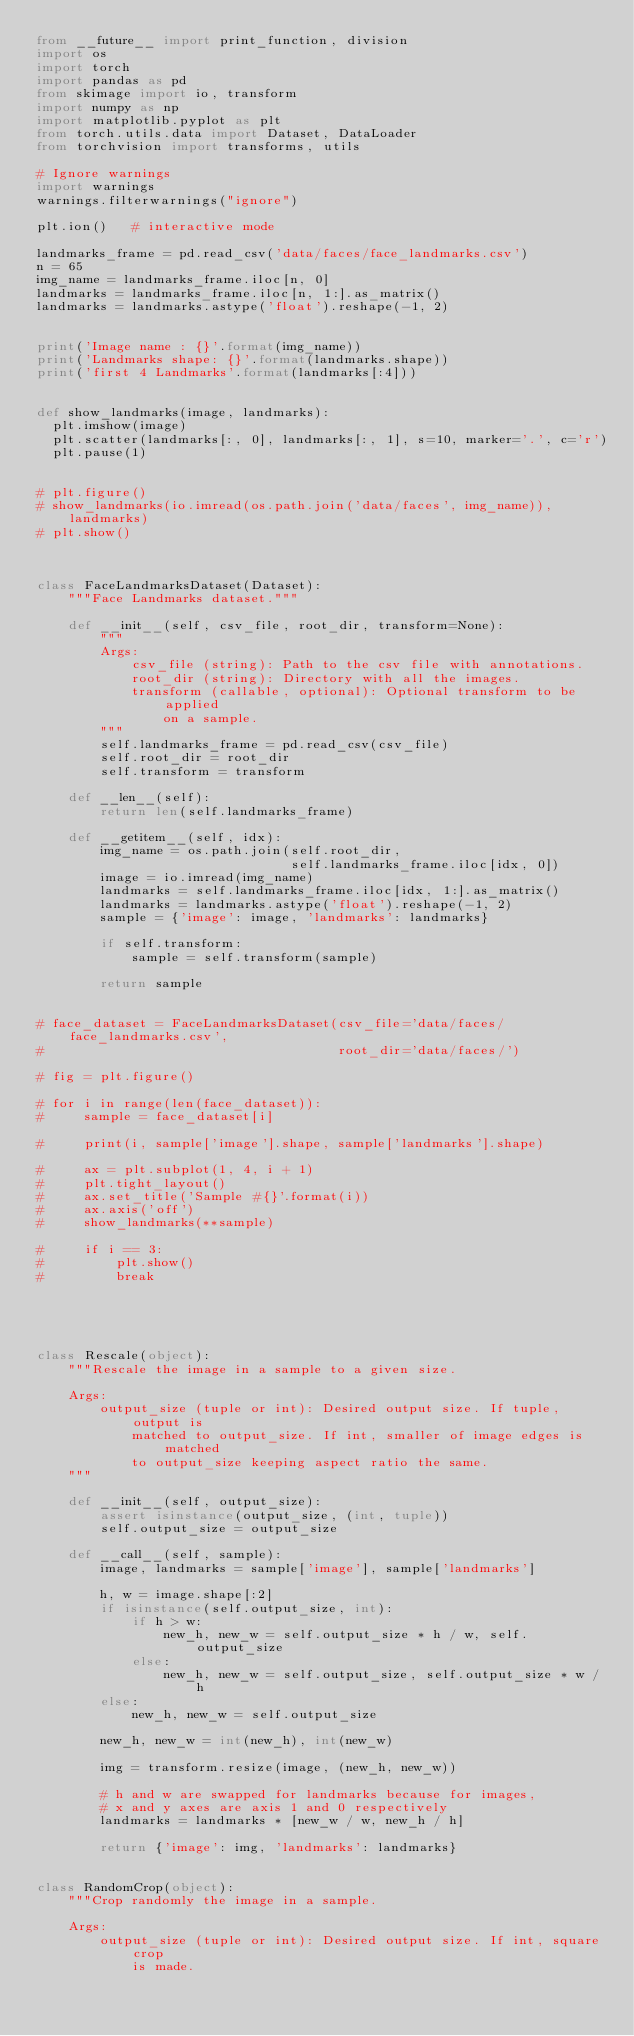<code> <loc_0><loc_0><loc_500><loc_500><_Python_>from __future__ import print_function, division
import os
import torch
import pandas as pd
from skimage import io, transform
import numpy as np
import matplotlib.pyplot as plt
from torch.utils.data import Dataset, DataLoader
from torchvision import transforms, utils

# Ignore warnings
import warnings
warnings.filterwarnings("ignore")

plt.ion()   # interactive mode

landmarks_frame = pd.read_csv('data/faces/face_landmarks.csv')
n = 65
img_name = landmarks_frame.iloc[n, 0]
landmarks = landmarks_frame.iloc[n, 1:].as_matrix()
landmarks = landmarks.astype('float').reshape(-1, 2)


print('Image name : {}'.format(img_name))
print('Landmarks shape: {}'.format(landmarks.shape))
print('first 4 Landmarks'.format(landmarks[:4]))


def show_landmarks(image, landmarks):
	plt.imshow(image)
	plt.scatter(landmarks[:, 0], landmarks[:, 1], s=10, marker='.', c='r')
	plt.pause(1)


# plt.figure()
# show_landmarks(io.imread(os.path.join('data/faces', img_name)), landmarks)
# plt.show()



class FaceLandmarksDataset(Dataset):
    """Face Landmarks dataset."""

    def __init__(self, csv_file, root_dir, transform=None):
        """
        Args:
            csv_file (string): Path to the csv file with annotations.
            root_dir (string): Directory with all the images.
            transform (callable, optional): Optional transform to be applied
                on a sample.
        """
        self.landmarks_frame = pd.read_csv(csv_file)
        self.root_dir = root_dir
        self.transform = transform

    def __len__(self):
        return len(self.landmarks_frame)

    def __getitem__(self, idx):
        img_name = os.path.join(self.root_dir,
                                self.landmarks_frame.iloc[idx, 0])
        image = io.imread(img_name)
        landmarks = self.landmarks_frame.iloc[idx, 1:].as_matrix()
        landmarks = landmarks.astype('float').reshape(-1, 2)
        sample = {'image': image, 'landmarks': landmarks}

        if self.transform:
            sample = self.transform(sample)

        return sample


# face_dataset = FaceLandmarksDataset(csv_file='data/faces/face_landmarks.csv',
#                                     root_dir='data/faces/')

# fig = plt.figure()

# for i in range(len(face_dataset)):
#     sample = face_dataset[i]

#     print(i, sample['image'].shape, sample['landmarks'].shape)

#     ax = plt.subplot(1, 4, i + 1)
#     plt.tight_layout()
#     ax.set_title('Sample #{}'.format(i))
#     ax.axis('off')
#     show_landmarks(**sample)

#     if i == 3:
#         plt.show()
#         break





class Rescale(object):
    """Rescale the image in a sample to a given size.

    Args:
        output_size (tuple or int): Desired output size. If tuple, output is
            matched to output_size. If int, smaller of image edges is matched
            to output_size keeping aspect ratio the same.
    """

    def __init__(self, output_size):
        assert isinstance(output_size, (int, tuple))
        self.output_size = output_size

    def __call__(self, sample):
        image, landmarks = sample['image'], sample['landmarks']

        h, w = image.shape[:2]
        if isinstance(self.output_size, int):
            if h > w:
                new_h, new_w = self.output_size * h / w, self.output_size
            else:
                new_h, new_w = self.output_size, self.output_size * w / h
        else:
            new_h, new_w = self.output_size

        new_h, new_w = int(new_h), int(new_w)

        img = transform.resize(image, (new_h, new_w))

        # h and w are swapped for landmarks because for images,
        # x and y axes are axis 1 and 0 respectively
        landmarks = landmarks * [new_w / w, new_h / h]

        return {'image': img, 'landmarks': landmarks}


class RandomCrop(object):
    """Crop randomly the image in a sample.

    Args:
        output_size (tuple or int): Desired output size. If int, square crop
            is made.</code> 